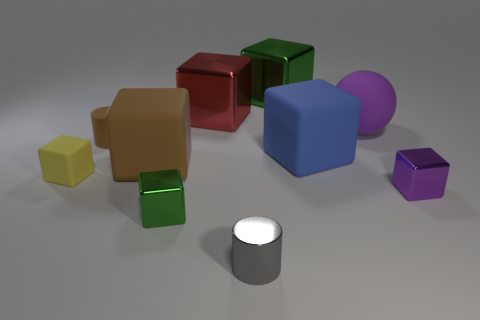Are there any shapes that appear more than once, and if so, what colors are they? Yes, the cube shape appears multiple times. There are cubes in red, green, yellow, brown, blue, and purple colors. 